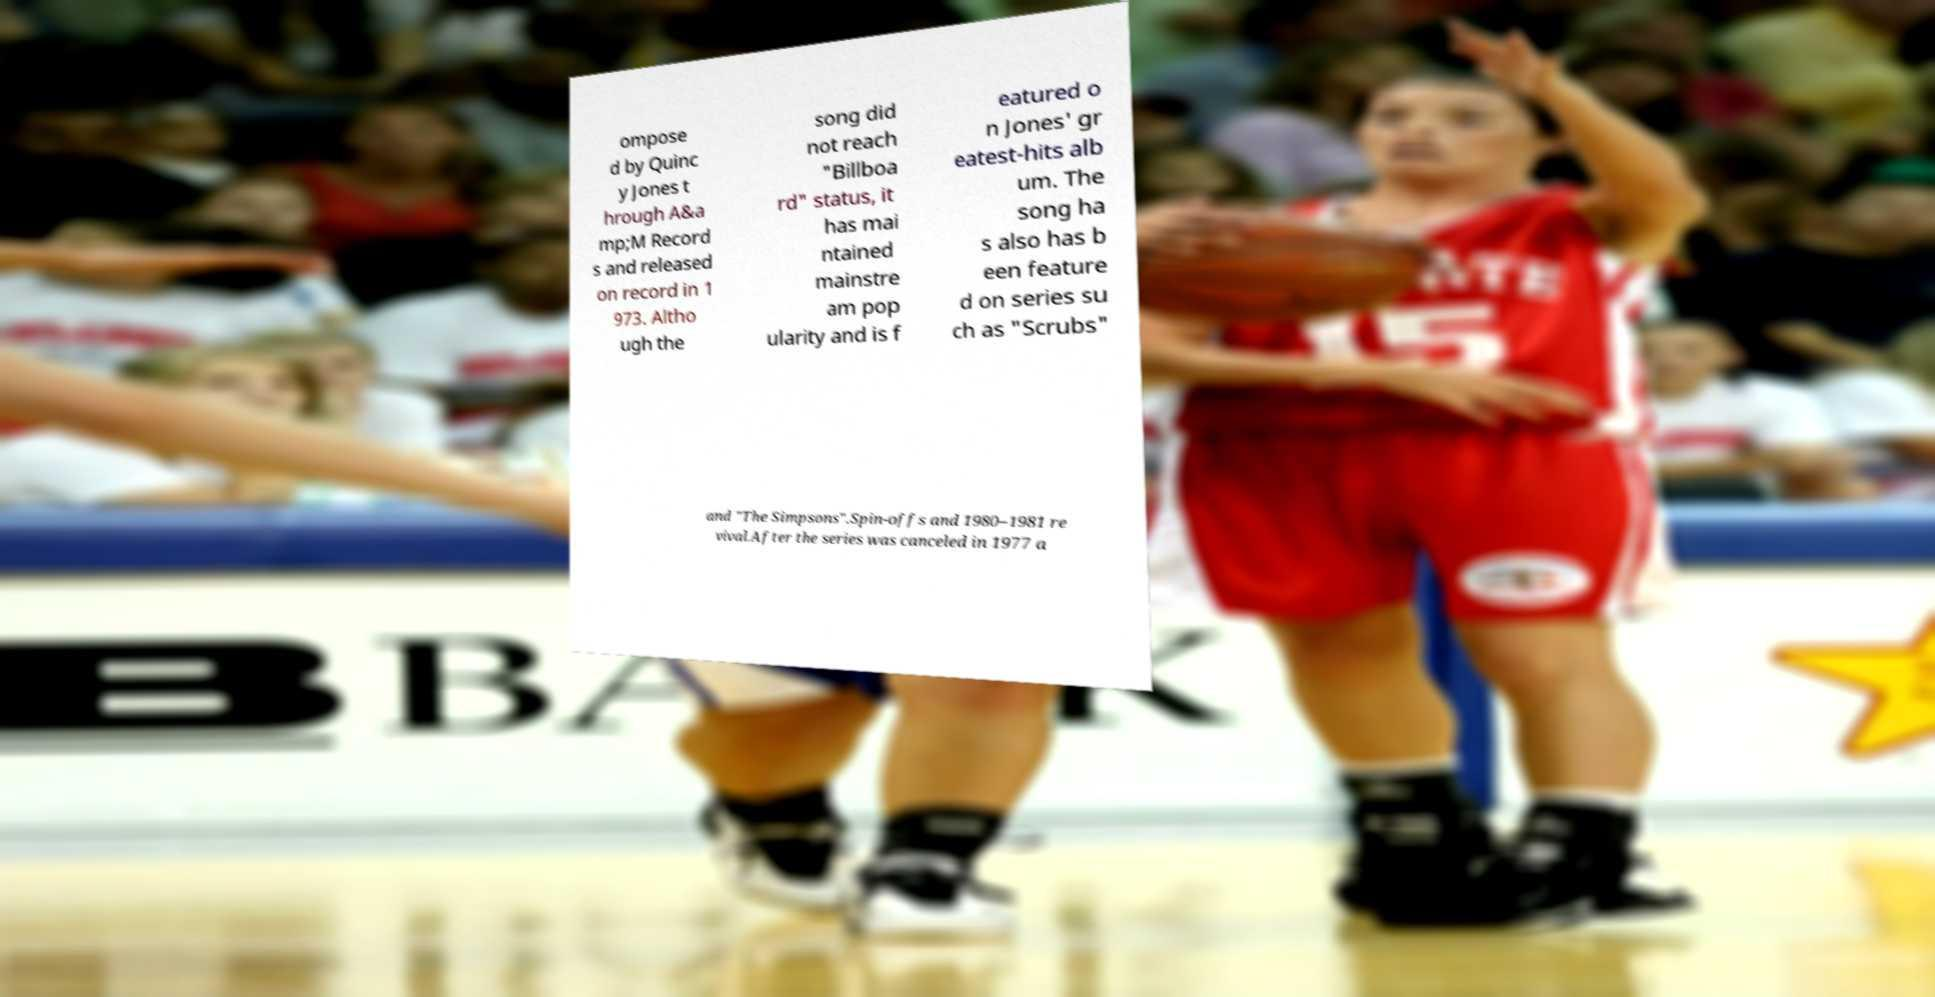For documentation purposes, I need the text within this image transcribed. Could you provide that? ompose d by Quinc y Jones t hrough A&a mp;M Record s and released on record in 1 973. Altho ugh the song did not reach "Billboa rd" status, it has mai ntained mainstre am pop ularity and is f eatured o n Jones' gr eatest-hits alb um. The song ha s also has b een feature d on series su ch as "Scrubs" and "The Simpsons".Spin-offs and 1980–1981 re vival.After the series was canceled in 1977 a 